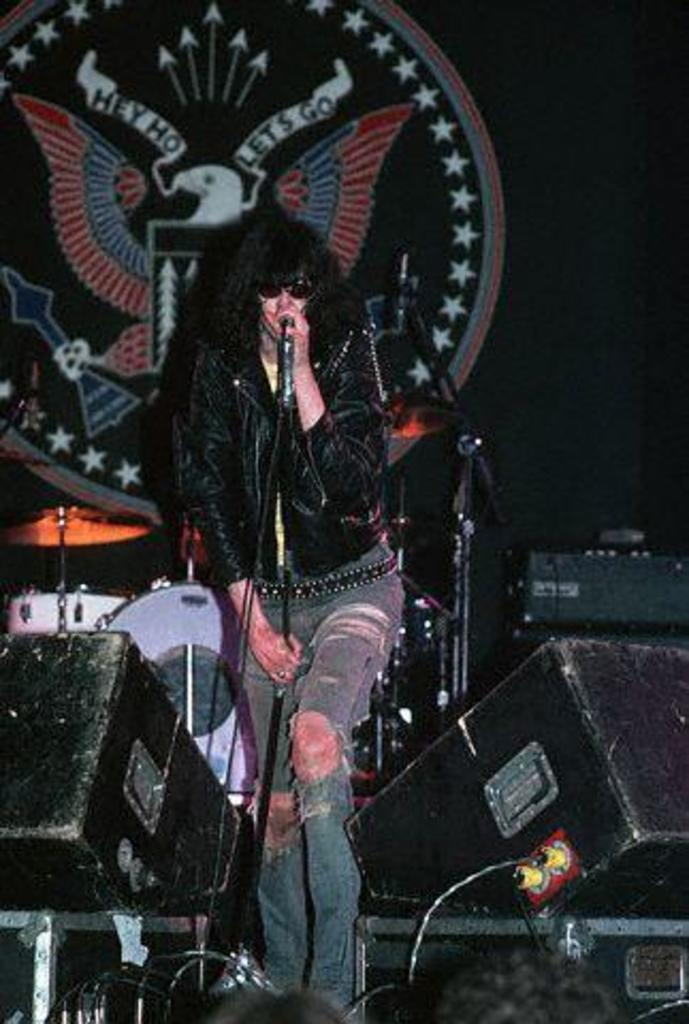Who is the main subject in the image? There is a woman in the image. What is the woman wearing? The woman is wearing a black jacket. What is the woman doing in the image? The woman is singing into a microphone. What can be seen in the background of the image? There are speakers, a band setup, and a logo in the background of the image. What type of haircut does the coach have in the image? There is no coach present in the image, and therefore no haircut can be observed. How many passengers are visible in the image? There are no passengers present in the image; it features a woman singing into a microphone. 